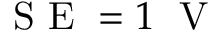<formula> <loc_0><loc_0><loc_500><loc_500>S E = 1 \, V</formula> 